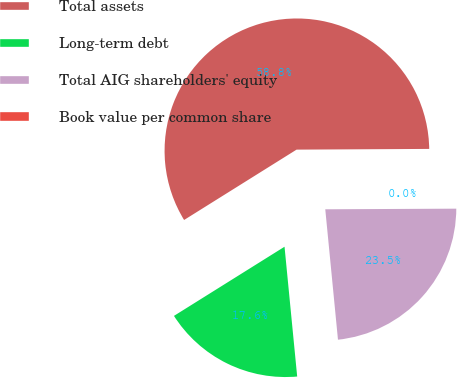Convert chart to OTSL. <chart><loc_0><loc_0><loc_500><loc_500><pie_chart><fcel>Total assets<fcel>Long-term debt<fcel>Total AIG shareholders' equity<fcel>Book value per common share<nl><fcel>58.81%<fcel>17.65%<fcel>23.53%<fcel>0.01%<nl></chart> 